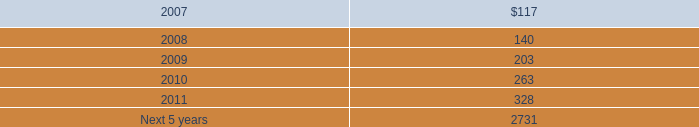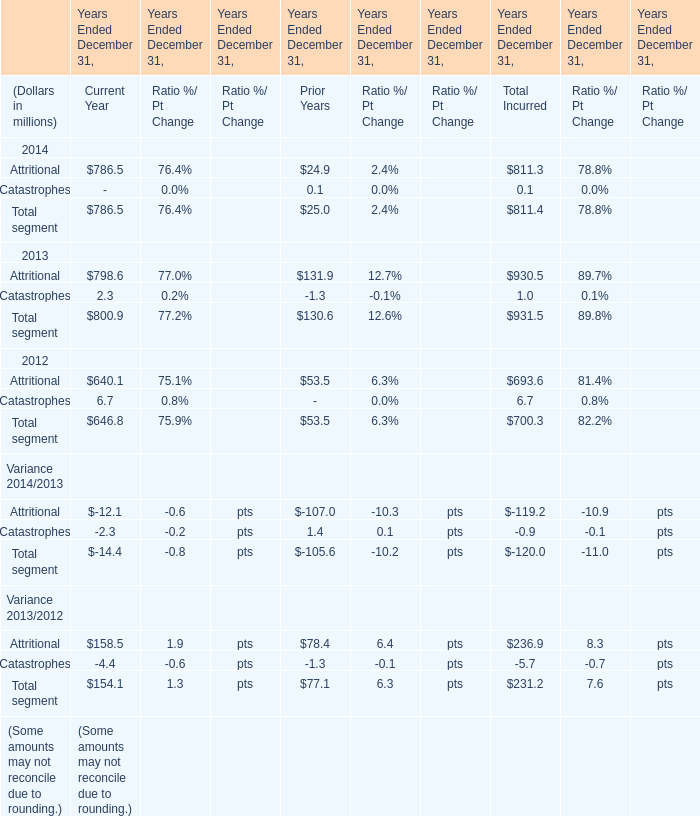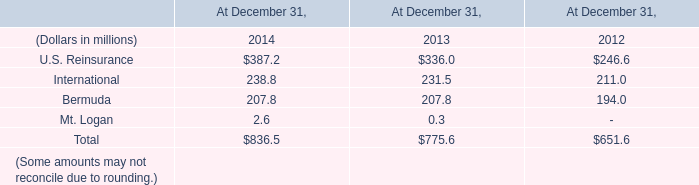What is the proportion of Attritional to the total in 2014? 
Computations: (811.3 / 811.4)
Answer: 0.99988. 